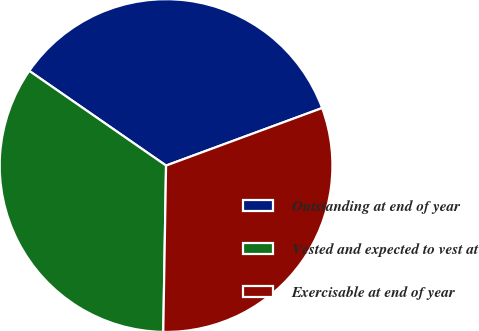Convert chart. <chart><loc_0><loc_0><loc_500><loc_500><pie_chart><fcel>Outstanding at end of year<fcel>Vested and expected to vest at<fcel>Exercisable at end of year<nl><fcel>34.74%<fcel>34.37%<fcel>30.89%<nl></chart> 